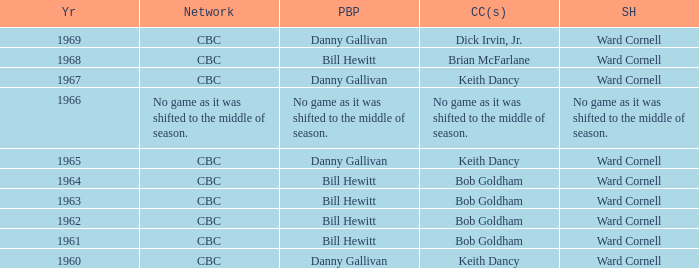Did the color analysts working alongside bill hewitt perform the play-by-play? Brian McFarlane, Bob Goldham, Bob Goldham, Bob Goldham, Bob Goldham. Can you parse all the data within this table? {'header': ['Yr', 'Network', 'PBP', 'CC(s)', 'SH'], 'rows': [['1969', 'CBC', 'Danny Gallivan', 'Dick Irvin, Jr.', 'Ward Cornell'], ['1968', 'CBC', 'Bill Hewitt', 'Brian McFarlane', 'Ward Cornell'], ['1967', 'CBC', 'Danny Gallivan', 'Keith Dancy', 'Ward Cornell'], ['1966', 'No game as it was shifted to the middle of season.', 'No game as it was shifted to the middle of season.', 'No game as it was shifted to the middle of season.', 'No game as it was shifted to the middle of season.'], ['1965', 'CBC', 'Danny Gallivan', 'Keith Dancy', 'Ward Cornell'], ['1964', 'CBC', 'Bill Hewitt', 'Bob Goldham', 'Ward Cornell'], ['1963', 'CBC', 'Bill Hewitt', 'Bob Goldham', 'Ward Cornell'], ['1962', 'CBC', 'Bill Hewitt', 'Bob Goldham', 'Ward Cornell'], ['1961', 'CBC', 'Bill Hewitt', 'Bob Goldham', 'Ward Cornell'], ['1960', 'CBC', 'Danny Gallivan', 'Keith Dancy', 'Ward Cornell']]} 